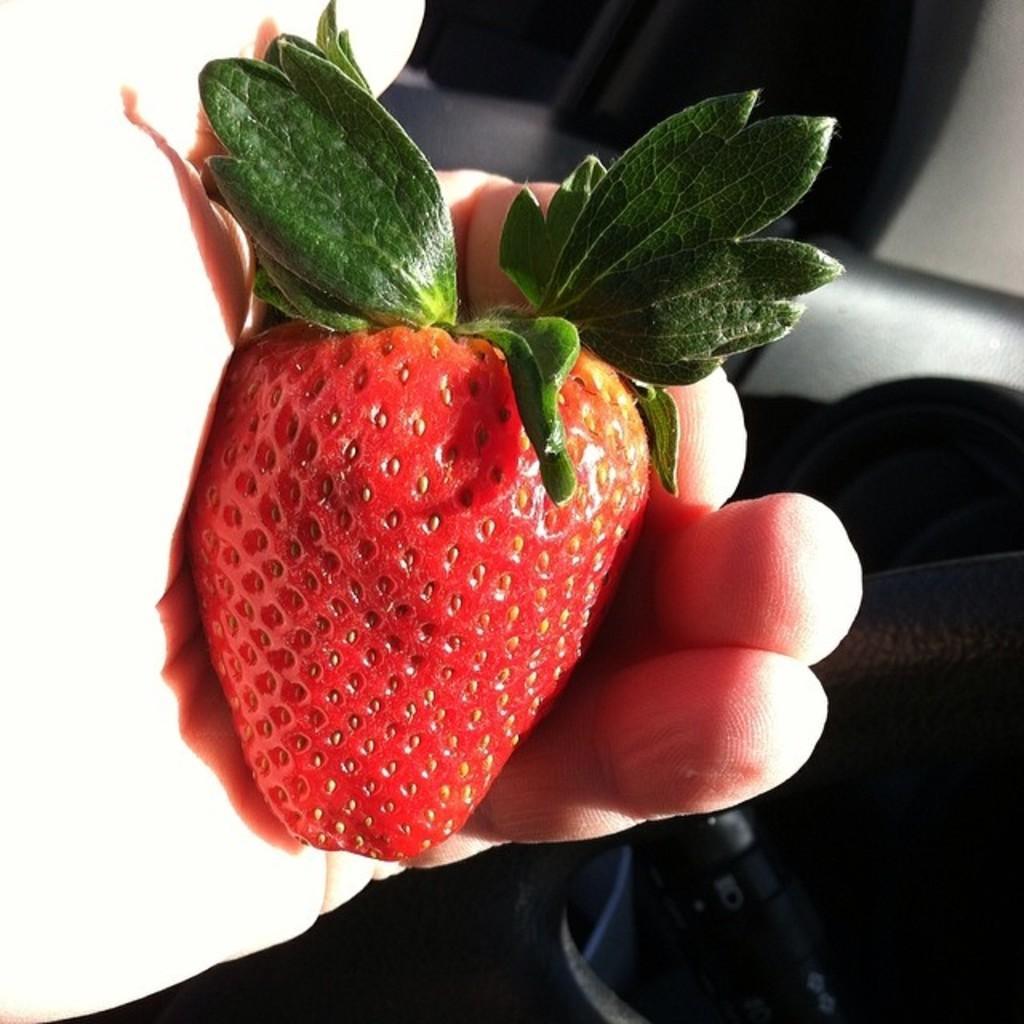Could you give a brief overview of what you see in this image? In this image there is a hand of a person holding a strawberry. At the top there are curtains to the wall. At the bottom there is a object. 